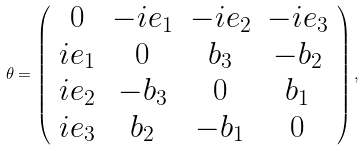Convert formula to latex. <formula><loc_0><loc_0><loc_500><loc_500>\theta = \left ( \begin{array} { c c c c } { 0 } & { { - i e _ { 1 } } } & { { - i e _ { 2 } } } & { { - i e _ { 3 } } } \\ { { i e _ { 1 } } } & { 0 } & { { b _ { 3 } } } & { { - b _ { 2 } } } \\ { { i e _ { 2 } } } & { { - b _ { 3 } } } & { 0 } & { { b _ { 1 } } } \\ { { i e _ { 3 } } } & { { b _ { 2 } } } & { { - b _ { 1 } } } & { 0 } \end{array} \right ) ,</formula> 